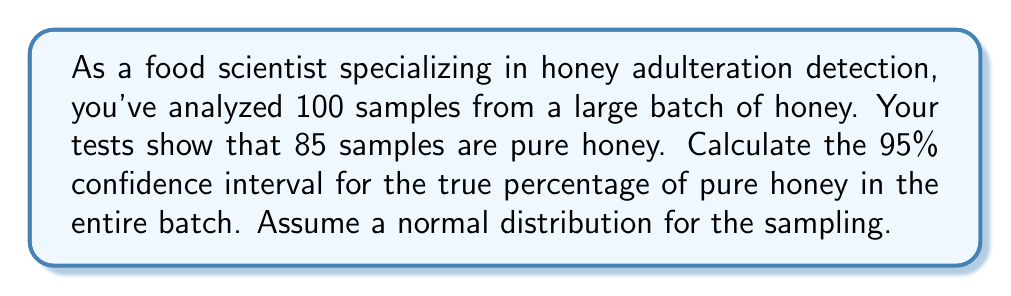What is the answer to this math problem? To calculate the confidence interval, we'll follow these steps:

1. Calculate the sample proportion:
   $\hat{p} = \frac{85}{100} = 0.85$

2. Calculate the standard error:
   $SE = \sqrt{\frac{\hat{p}(1-\hat{p})}{n}} = \sqrt{\frac{0.85(1-0.85)}{100}} = \sqrt{\frac{0.1275}{100}} = 0.0357$

3. For a 95% confidence interval, use z-score of 1.96 (from standard normal distribution table)

4. Calculate the margin of error:
   $ME = z \times SE = 1.96 \times 0.0357 = 0.0700$

5. Determine the confidence interval:
   $CI = \hat{p} \pm ME$
   $CI = 0.85 \pm 0.0700$
   $CI = (0.85 - 0.0700, 0.85 + 0.0700)$
   $CI = (0.7800, 0.9200)$

Therefore, we can be 95% confident that the true percentage of pure honey in the entire batch falls between 78.00% and 92.00%.
Answer: (78.00%, 92.00%) 